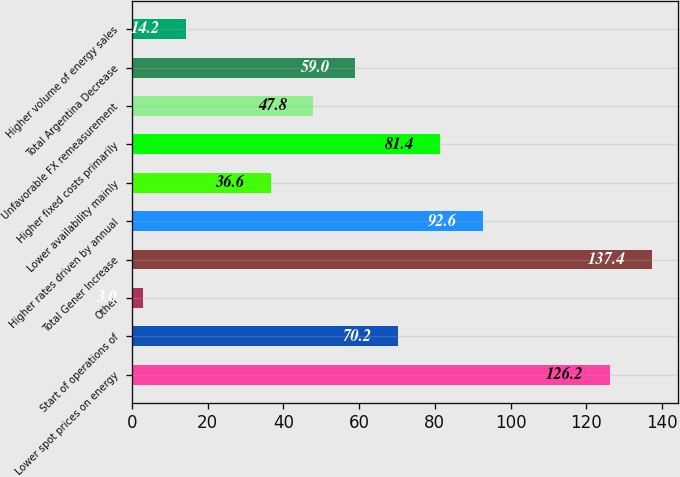<chart> <loc_0><loc_0><loc_500><loc_500><bar_chart><fcel>Lower spot prices on energy<fcel>Start of operations of<fcel>Other<fcel>Total Gener Increase<fcel>Higher rates driven by annual<fcel>Lower availability mainly<fcel>Higher fixed costs primarily<fcel>Unfavorable FX remeasurement<fcel>Total Argentina Decrease<fcel>Higher volume of energy sales<nl><fcel>126.2<fcel>70.2<fcel>3<fcel>137.4<fcel>92.6<fcel>36.6<fcel>81.4<fcel>47.8<fcel>59<fcel>14.2<nl></chart> 